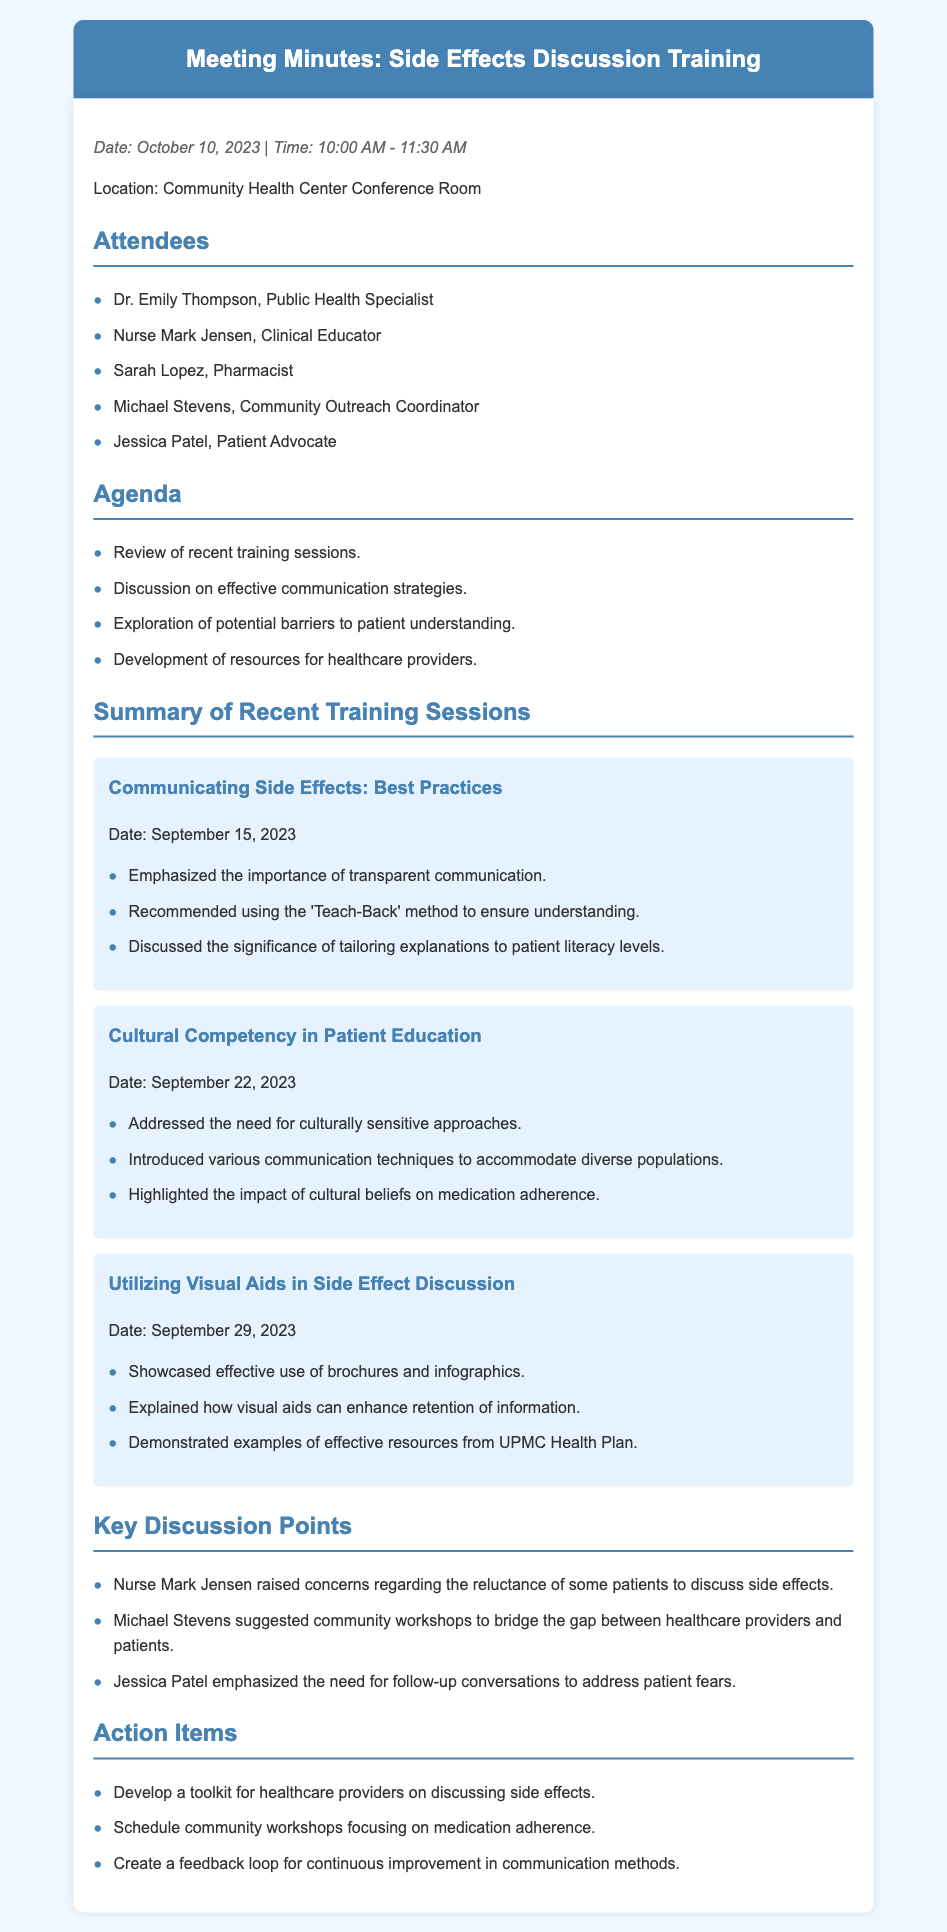What was the date of the meeting? The date of the meeting is mentioned at the beginning of the document.
Answer: October 10, 2023 Who facilitated the training session on communicating side effects? This information can be inferred from the attendees and session titles; however, the document does not specify a facilitator.
Answer: Not specified How many training sessions are summarized in the document? The document lists three training sessions in the summary section.
Answer: Three What method was recommended to ensure patient understanding? The summary of the first training session mentions a specific method for understanding.
Answer: Teach-Back Which training session focused on cultural approaches? This is found in the titles of the training sessions provided in the summary.
Answer: Cultural Competency in Patient Education What key point did Nurse Mark Jensen raise during the discussion? This is highlighted in the key discussion points section of the document.
Answer: Reluctance to discuss side effects What is one action item mentioned in the minutes? Action items are listed at the end of the document.
Answer: Develop a toolkit for healthcare providers What type of resources were showcased in the training session on visual aids? This information is found in the summary of the relevant session.
Answer: Brochures and infographics Who emphasized the need for follow-up conversations? The document attributes this statement to a specific attendee.
Answer: Jessica Patel 